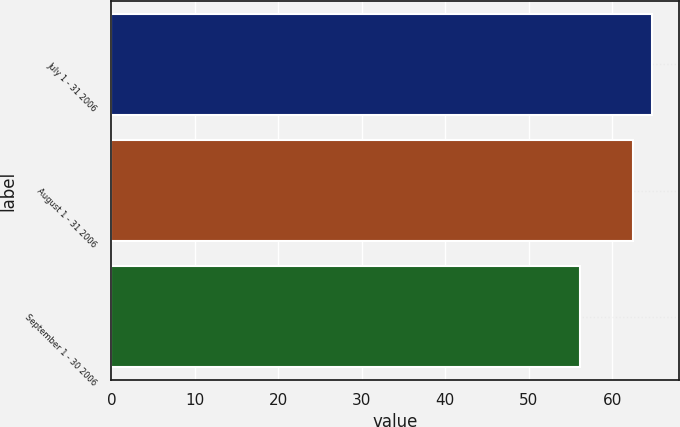Convert chart. <chart><loc_0><loc_0><loc_500><loc_500><bar_chart><fcel>July 1 - 31 2006<fcel>August 1 - 31 2006<fcel>September 1 - 30 2006<nl><fcel>64.75<fcel>62.54<fcel>56.11<nl></chart> 